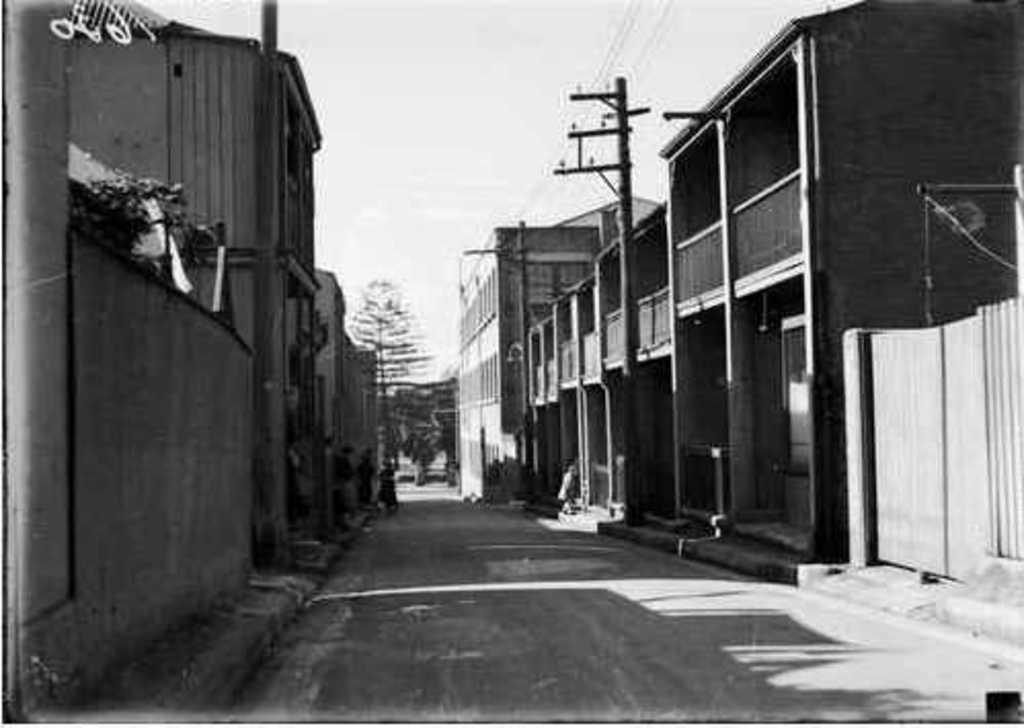How would you summarize this image in a sentence or two? This is a black and white image. At the bottom there is a road. On both sides of the road I can see the buildings. In the background there are some trees. At the top I can see the sky. 